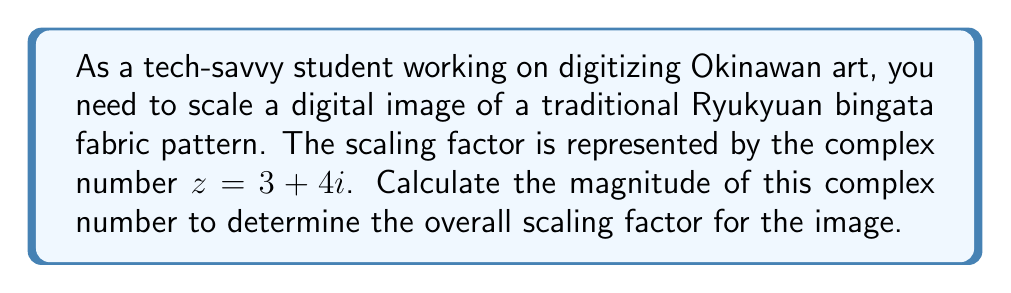Help me with this question. To calculate the magnitude of a complex number $z = a + bi$, we use the formula:

$$ |z| = \sqrt{a^2 + b^2} $$

Where $|z|$ represents the magnitude of the complex number.

For our given complex number $z = 3 + 4i$:
$a = 3$ and $b = 4$

Let's substitute these values into the formula:

$$ |z| = \sqrt{3^2 + 4^2} $$

$$ |z| = \sqrt{9 + 16} $$

$$ |z| = \sqrt{25} $$

$$ |z| = 5 $$

This magnitude represents the scaling factor for the image. A magnitude of 5 means that the image will be scaled up by a factor of 5 in both dimensions.
Answer: The magnitude of the complex number $z = 3 + 4i$ is 5. 